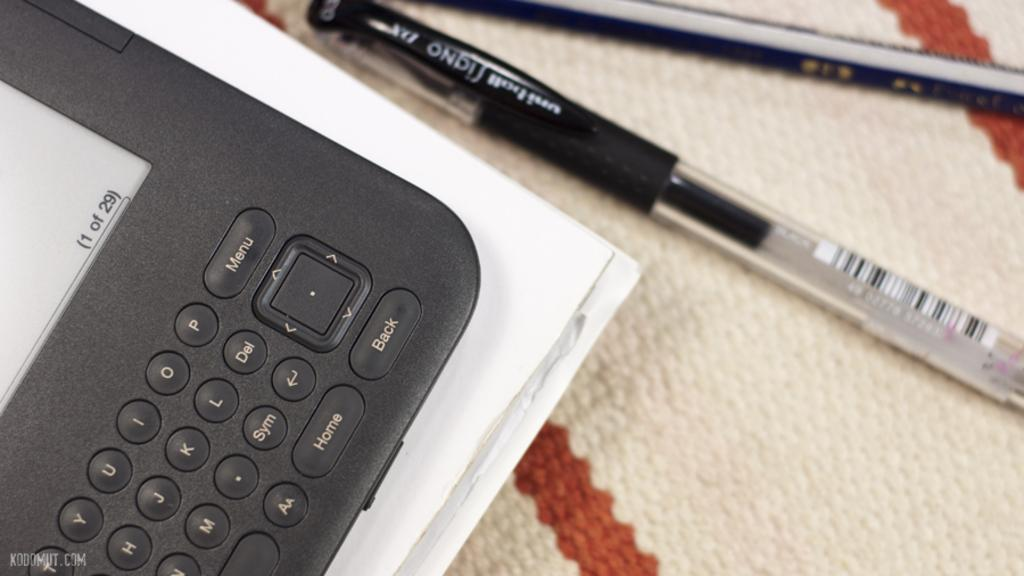<image>
Relay a brief, clear account of the picture shown. An electronic device has a screen with the information (1 of 29) in the bottom right corner. 